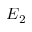<formula> <loc_0><loc_0><loc_500><loc_500>E _ { 2 }</formula> 